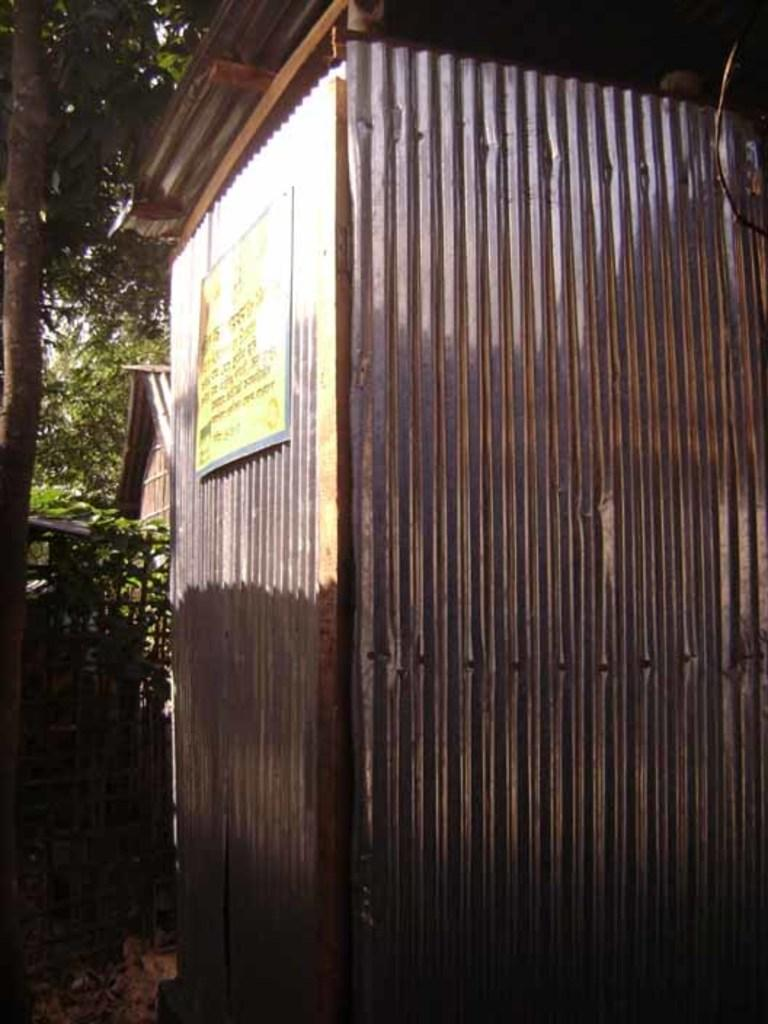What type of material is visible in the image? There are metal sheets in the image. What is attached to the metal sheets? There is a board pasted on the metal sheets. What can be seen in the background of the image? There are trees in the background of the image. How many sails can be seen on the metal sheets in the image? There are no sails present in the image; it features metal sheets with a board pasted on them. Are there any cobwebs visible on the metal sheets in the image? There is no mention of cobwebs in the image, which only features metal sheets and a board pasted on them. 